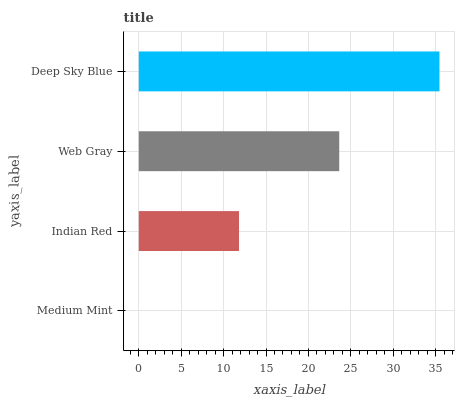Is Medium Mint the minimum?
Answer yes or no. Yes. Is Deep Sky Blue the maximum?
Answer yes or no. Yes. Is Indian Red the minimum?
Answer yes or no. No. Is Indian Red the maximum?
Answer yes or no. No. Is Indian Red greater than Medium Mint?
Answer yes or no. Yes. Is Medium Mint less than Indian Red?
Answer yes or no. Yes. Is Medium Mint greater than Indian Red?
Answer yes or no. No. Is Indian Red less than Medium Mint?
Answer yes or no. No. Is Web Gray the high median?
Answer yes or no. Yes. Is Indian Red the low median?
Answer yes or no. Yes. Is Deep Sky Blue the high median?
Answer yes or no. No. Is Medium Mint the low median?
Answer yes or no. No. 